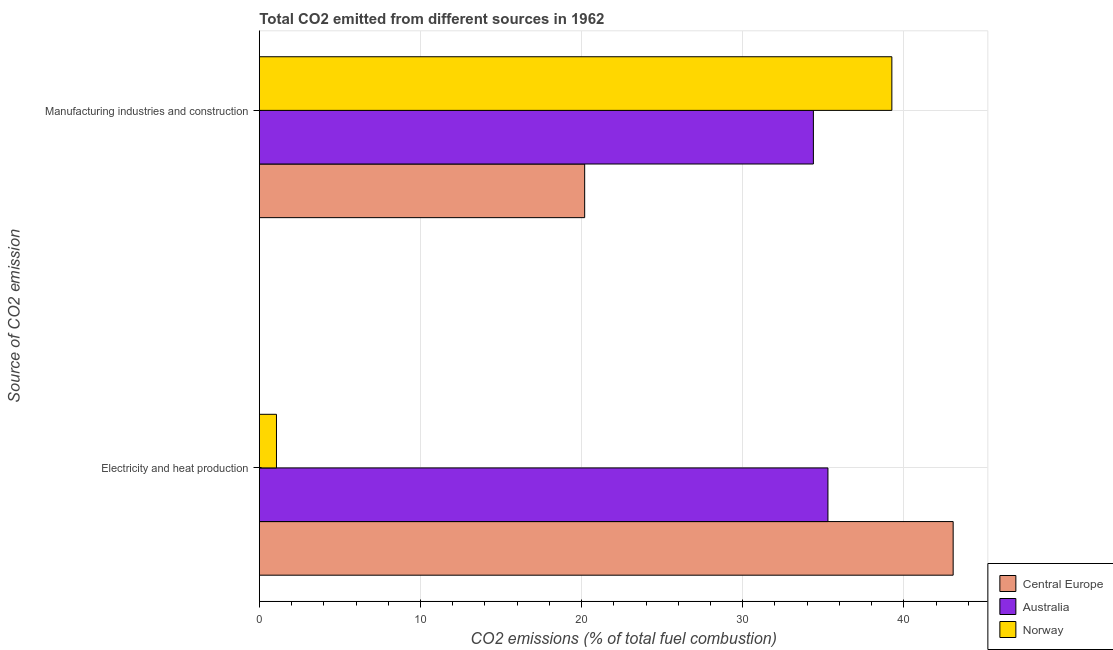How many different coloured bars are there?
Make the answer very short. 3. Are the number of bars per tick equal to the number of legend labels?
Offer a terse response. Yes. Are the number of bars on each tick of the Y-axis equal?
Offer a terse response. Yes. How many bars are there on the 1st tick from the top?
Your answer should be very brief. 3. What is the label of the 1st group of bars from the top?
Make the answer very short. Manufacturing industries and construction. What is the co2 emissions due to electricity and heat production in Australia?
Ensure brevity in your answer.  35.29. Across all countries, what is the maximum co2 emissions due to electricity and heat production?
Ensure brevity in your answer.  43.06. Across all countries, what is the minimum co2 emissions due to manufacturing industries?
Ensure brevity in your answer.  20.19. In which country was the co2 emissions due to electricity and heat production maximum?
Keep it short and to the point. Central Europe. In which country was the co2 emissions due to electricity and heat production minimum?
Your answer should be very brief. Norway. What is the total co2 emissions due to electricity and heat production in the graph?
Ensure brevity in your answer.  79.41. What is the difference between the co2 emissions due to manufacturing industries in Norway and that in Central Europe?
Your answer should be compact. 19.06. What is the difference between the co2 emissions due to electricity and heat production in Central Europe and the co2 emissions due to manufacturing industries in Australia?
Ensure brevity in your answer.  8.68. What is the average co2 emissions due to manufacturing industries per country?
Your response must be concise. 31.28. What is the difference between the co2 emissions due to manufacturing industries and co2 emissions due to electricity and heat production in Central Europe?
Your response must be concise. -22.87. In how many countries, is the co2 emissions due to electricity and heat production greater than 6 %?
Your answer should be compact. 2. What is the ratio of the co2 emissions due to manufacturing industries in Norway to that in Central Europe?
Offer a terse response. 1.94. Is the co2 emissions due to manufacturing industries in Norway less than that in Central Europe?
Your response must be concise. No. In how many countries, is the co2 emissions due to manufacturing industries greater than the average co2 emissions due to manufacturing industries taken over all countries?
Keep it short and to the point. 2. What does the 2nd bar from the top in Electricity and heat production represents?
Provide a succinct answer. Australia. Are the values on the major ticks of X-axis written in scientific E-notation?
Offer a terse response. No. Does the graph contain any zero values?
Keep it short and to the point. No. Does the graph contain grids?
Provide a succinct answer. Yes. How are the legend labels stacked?
Your response must be concise. Vertical. What is the title of the graph?
Make the answer very short. Total CO2 emitted from different sources in 1962. Does "Cyprus" appear as one of the legend labels in the graph?
Give a very brief answer. No. What is the label or title of the X-axis?
Your answer should be very brief. CO2 emissions (% of total fuel combustion). What is the label or title of the Y-axis?
Give a very brief answer. Source of CO2 emission. What is the CO2 emissions (% of total fuel combustion) in Central Europe in Electricity and heat production?
Provide a short and direct response. 43.06. What is the CO2 emissions (% of total fuel combustion) of Australia in Electricity and heat production?
Your response must be concise. 35.29. What is the CO2 emissions (% of total fuel combustion) of Norway in Electricity and heat production?
Your answer should be very brief. 1.06. What is the CO2 emissions (% of total fuel combustion) in Central Europe in Manufacturing industries and construction?
Your response must be concise. 20.19. What is the CO2 emissions (% of total fuel combustion) of Australia in Manufacturing industries and construction?
Ensure brevity in your answer.  34.39. What is the CO2 emissions (% of total fuel combustion) in Norway in Manufacturing industries and construction?
Your response must be concise. 39.26. Across all Source of CO2 emission, what is the maximum CO2 emissions (% of total fuel combustion) in Central Europe?
Make the answer very short. 43.06. Across all Source of CO2 emission, what is the maximum CO2 emissions (% of total fuel combustion) in Australia?
Provide a succinct answer. 35.29. Across all Source of CO2 emission, what is the maximum CO2 emissions (% of total fuel combustion) of Norway?
Provide a succinct answer. 39.26. Across all Source of CO2 emission, what is the minimum CO2 emissions (% of total fuel combustion) in Central Europe?
Give a very brief answer. 20.19. Across all Source of CO2 emission, what is the minimum CO2 emissions (% of total fuel combustion) of Australia?
Provide a short and direct response. 34.39. Across all Source of CO2 emission, what is the minimum CO2 emissions (% of total fuel combustion) in Norway?
Your answer should be very brief. 1.06. What is the total CO2 emissions (% of total fuel combustion) in Central Europe in the graph?
Your answer should be very brief. 63.25. What is the total CO2 emissions (% of total fuel combustion) of Australia in the graph?
Your answer should be compact. 69.67. What is the total CO2 emissions (% of total fuel combustion) in Norway in the graph?
Make the answer very short. 40.32. What is the difference between the CO2 emissions (% of total fuel combustion) in Central Europe in Electricity and heat production and that in Manufacturing industries and construction?
Your answer should be very brief. 22.87. What is the difference between the CO2 emissions (% of total fuel combustion) of Australia in Electricity and heat production and that in Manufacturing industries and construction?
Provide a succinct answer. 0.9. What is the difference between the CO2 emissions (% of total fuel combustion) in Norway in Electricity and heat production and that in Manufacturing industries and construction?
Provide a succinct answer. -38.19. What is the difference between the CO2 emissions (% of total fuel combustion) of Central Europe in Electricity and heat production and the CO2 emissions (% of total fuel combustion) of Australia in Manufacturing industries and construction?
Provide a succinct answer. 8.68. What is the difference between the CO2 emissions (% of total fuel combustion) in Central Europe in Electricity and heat production and the CO2 emissions (% of total fuel combustion) in Norway in Manufacturing industries and construction?
Your answer should be compact. 3.8. What is the difference between the CO2 emissions (% of total fuel combustion) in Australia in Electricity and heat production and the CO2 emissions (% of total fuel combustion) in Norway in Manufacturing industries and construction?
Ensure brevity in your answer.  -3.97. What is the average CO2 emissions (% of total fuel combustion) of Central Europe per Source of CO2 emission?
Provide a succinct answer. 31.63. What is the average CO2 emissions (% of total fuel combustion) in Australia per Source of CO2 emission?
Your response must be concise. 34.84. What is the average CO2 emissions (% of total fuel combustion) of Norway per Source of CO2 emission?
Provide a succinct answer. 20.16. What is the difference between the CO2 emissions (% of total fuel combustion) of Central Europe and CO2 emissions (% of total fuel combustion) of Australia in Electricity and heat production?
Offer a terse response. 7.77. What is the difference between the CO2 emissions (% of total fuel combustion) in Central Europe and CO2 emissions (% of total fuel combustion) in Norway in Electricity and heat production?
Make the answer very short. 42. What is the difference between the CO2 emissions (% of total fuel combustion) of Australia and CO2 emissions (% of total fuel combustion) of Norway in Electricity and heat production?
Ensure brevity in your answer.  34.23. What is the difference between the CO2 emissions (% of total fuel combustion) of Central Europe and CO2 emissions (% of total fuel combustion) of Australia in Manufacturing industries and construction?
Make the answer very short. -14.19. What is the difference between the CO2 emissions (% of total fuel combustion) of Central Europe and CO2 emissions (% of total fuel combustion) of Norway in Manufacturing industries and construction?
Provide a short and direct response. -19.06. What is the difference between the CO2 emissions (% of total fuel combustion) in Australia and CO2 emissions (% of total fuel combustion) in Norway in Manufacturing industries and construction?
Keep it short and to the point. -4.87. What is the ratio of the CO2 emissions (% of total fuel combustion) in Central Europe in Electricity and heat production to that in Manufacturing industries and construction?
Provide a succinct answer. 2.13. What is the ratio of the CO2 emissions (% of total fuel combustion) in Australia in Electricity and heat production to that in Manufacturing industries and construction?
Your answer should be compact. 1.03. What is the ratio of the CO2 emissions (% of total fuel combustion) in Norway in Electricity and heat production to that in Manufacturing industries and construction?
Offer a very short reply. 0.03. What is the difference between the highest and the second highest CO2 emissions (% of total fuel combustion) in Central Europe?
Your answer should be compact. 22.87. What is the difference between the highest and the second highest CO2 emissions (% of total fuel combustion) of Australia?
Offer a terse response. 0.9. What is the difference between the highest and the second highest CO2 emissions (% of total fuel combustion) of Norway?
Offer a very short reply. 38.19. What is the difference between the highest and the lowest CO2 emissions (% of total fuel combustion) of Central Europe?
Provide a short and direct response. 22.87. What is the difference between the highest and the lowest CO2 emissions (% of total fuel combustion) in Australia?
Provide a short and direct response. 0.9. What is the difference between the highest and the lowest CO2 emissions (% of total fuel combustion) in Norway?
Your answer should be very brief. 38.19. 